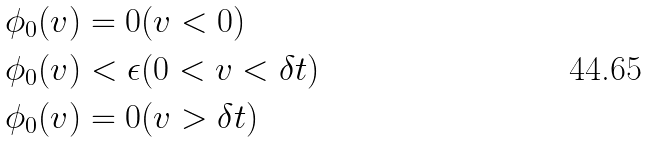<formula> <loc_0><loc_0><loc_500><loc_500>\phi _ { 0 } ( v ) & = 0 ( v < 0 ) \\ \phi _ { 0 } ( v ) & < \epsilon ( 0 < v < \delta t ) \\ \phi _ { 0 } ( v ) & = 0 ( v > \delta t )</formula> 